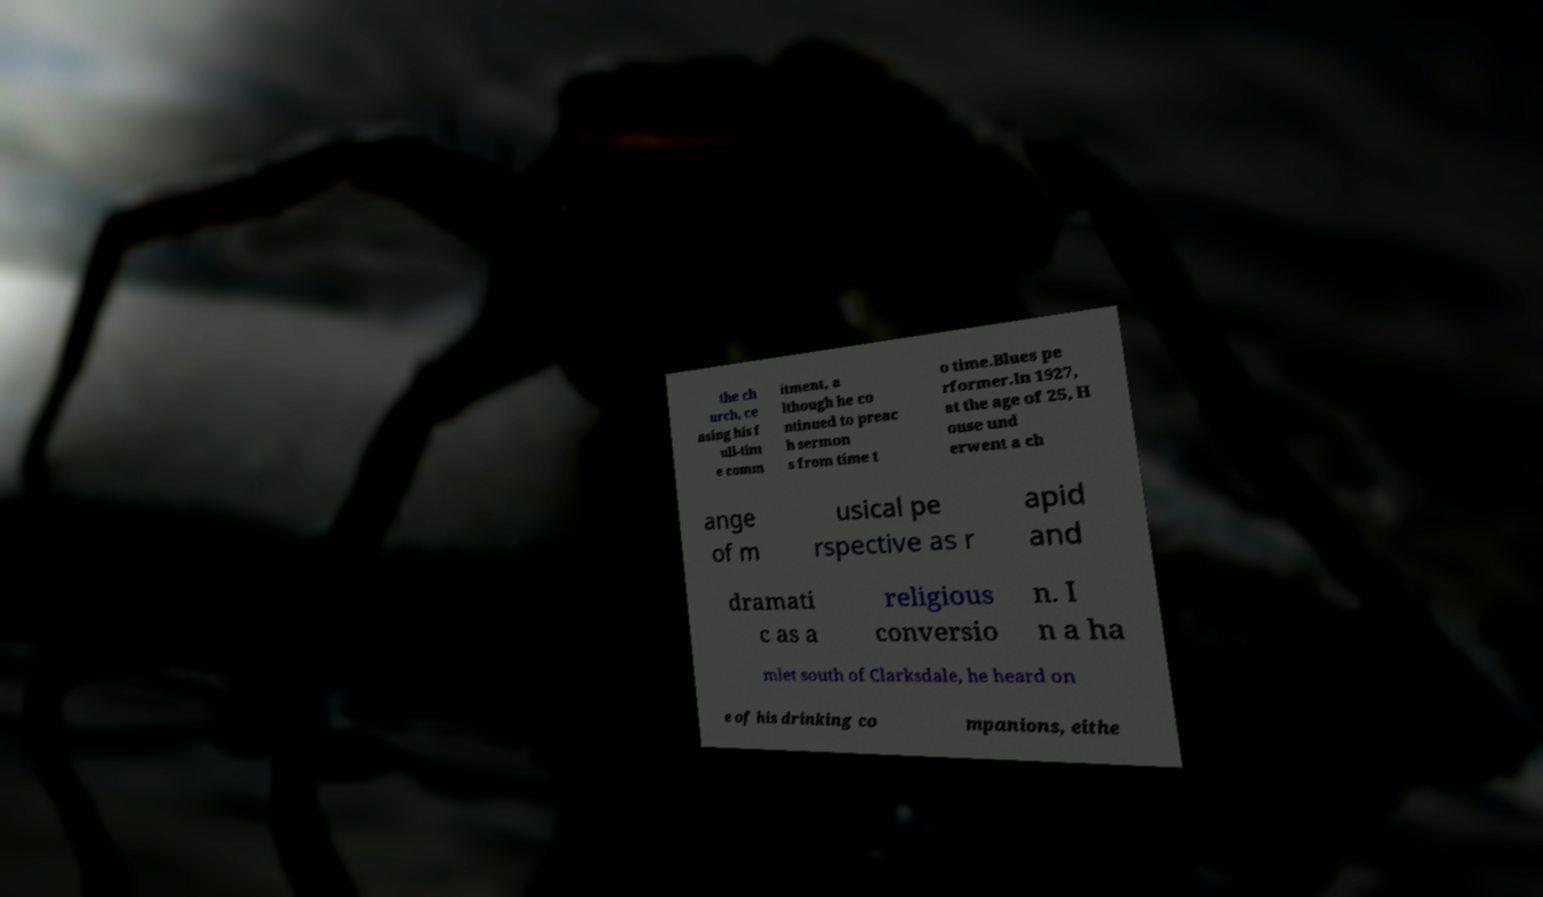Can you accurately transcribe the text from the provided image for me? the ch urch, ce asing his f ull-tim e comm itment, a lthough he co ntinued to preac h sermon s from time t o time.Blues pe rformer.In 1927, at the age of 25, H ouse und erwent a ch ange of m usical pe rspective as r apid and dramati c as a religious conversio n. I n a ha mlet south of Clarksdale, he heard on e of his drinking co mpanions, eithe 